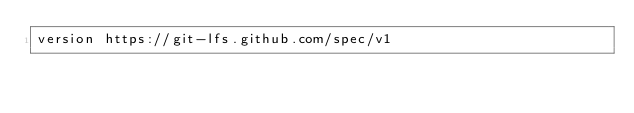<code> <loc_0><loc_0><loc_500><loc_500><_SQL_>version https://git-lfs.github.com/spec/v1</code> 